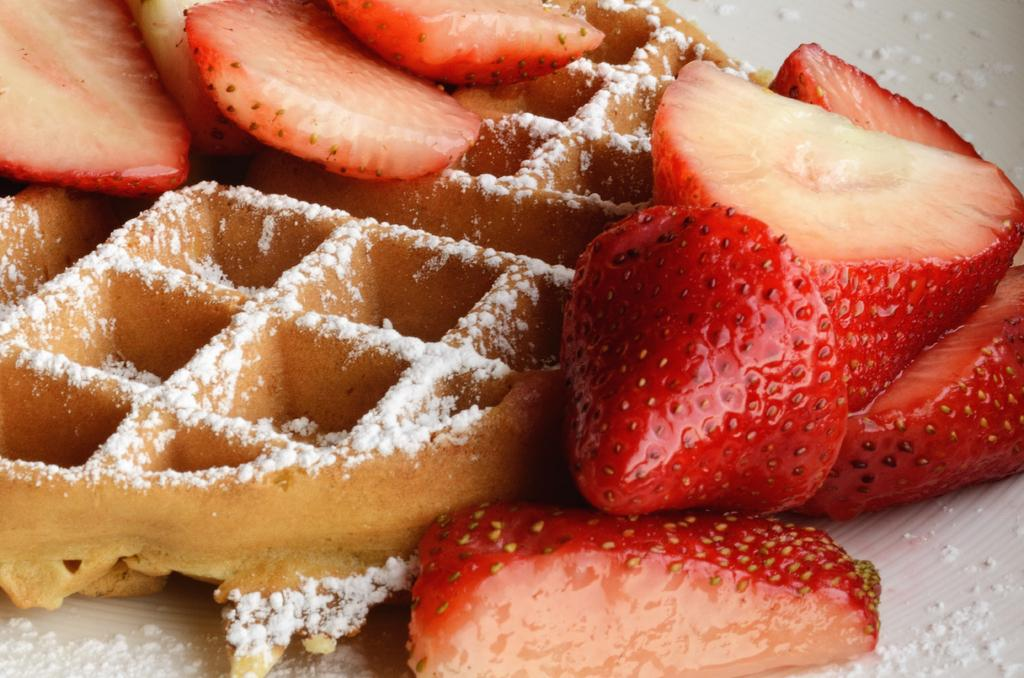What is: What is the main subject of the image? There is a cake in the center of the image. What decorations are on the cake? There are strawberry slices on the cake. Are there any other food items on the cake besides strawberry slices? Yes, there is at least one other food item on the cake. What month is the cat celebrating its birthday in the image? There is no cat present in the image, and therefore no birthday celebration involving a cat. 